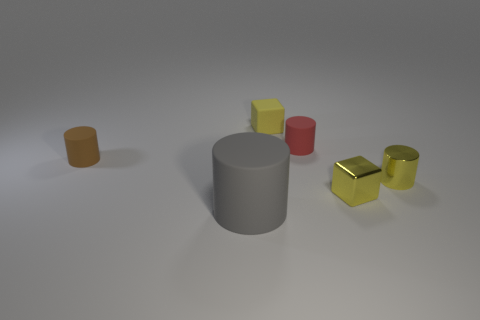Add 1 gray matte objects. How many objects exist? 7 Subtract all big gray rubber cylinders. How many cylinders are left? 3 Subtract all gray cylinders. How many cylinders are left? 3 Subtract 2 cubes. How many cubes are left? 0 Subtract all cylinders. How many objects are left? 2 Add 2 tiny yellow rubber spheres. How many tiny yellow rubber spheres exist? 2 Subtract 0 green cubes. How many objects are left? 6 Subtract all blue cylinders. Subtract all blue balls. How many cylinders are left? 4 Subtract all yellow cubes. How many yellow cylinders are left? 1 Subtract all large yellow rubber objects. Subtract all red matte cylinders. How many objects are left? 5 